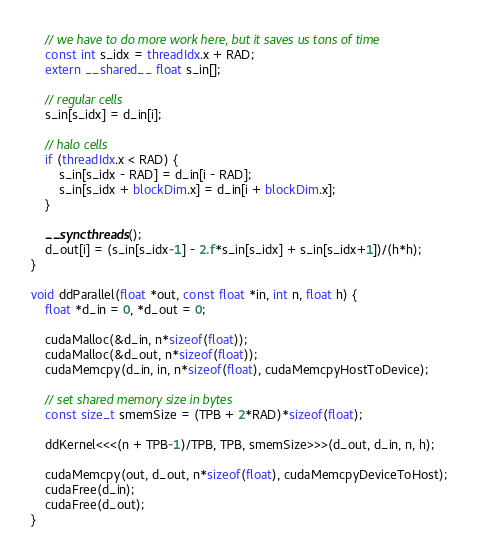Convert code to text. <code><loc_0><loc_0><loc_500><loc_500><_Cuda_>
    // we have to do more work here, but it saves us tons of time
    const int s_idx = threadIdx.x + RAD;
    extern __shared__ float s_in[];

    // regular cells
    s_in[s_idx] = d_in[i];

    // halo cells
    if (threadIdx.x < RAD) {
        s_in[s_idx - RAD] = d_in[i - RAD];
        s_in[s_idx + blockDim.x] = d_in[i + blockDim.x];
    }

    __syncthreads();
    d_out[i] = (s_in[s_idx-1] - 2.f*s_in[s_idx] + s_in[s_idx+1])/(h*h);
}

void ddParallel(float *out, const float *in, int n, float h) {
    float *d_in = 0, *d_out = 0;

    cudaMalloc(&d_in, n*sizeof(float));
    cudaMalloc(&d_out, n*sizeof(float));
    cudaMemcpy(d_in, in, n*sizeof(float), cudaMemcpyHostToDevice);

    // set shared memory size in bytes
    const size_t smemSize = (TPB + 2*RAD)*sizeof(float);

    ddKernel<<<(n + TPB-1)/TPB, TPB, smemSize>>>(d_out, d_in, n, h);

    cudaMemcpy(out, d_out, n*sizeof(float), cudaMemcpyDeviceToHost);
    cudaFree(d_in);
    cudaFree(d_out);
}
</code> 